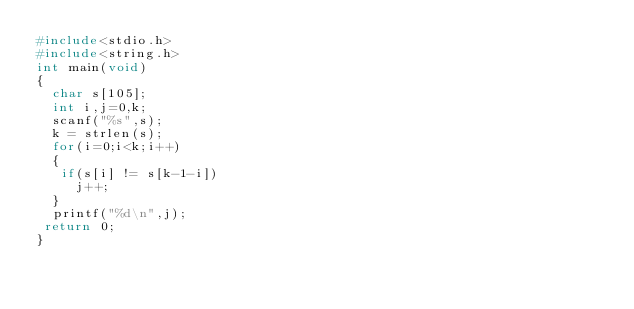<code> <loc_0><loc_0><loc_500><loc_500><_C_>#include<stdio.h>
#include<string.h>
int main(void)
{
  char s[105];
  int i,j=0,k;
  scanf("%s",s);
  k = strlen(s);
  for(i=0;i<k;i++)
  {
   if(s[i] != s[k-1-i])
     j++;
  }
  printf("%d\n",j); 
 return 0; 
}</code> 